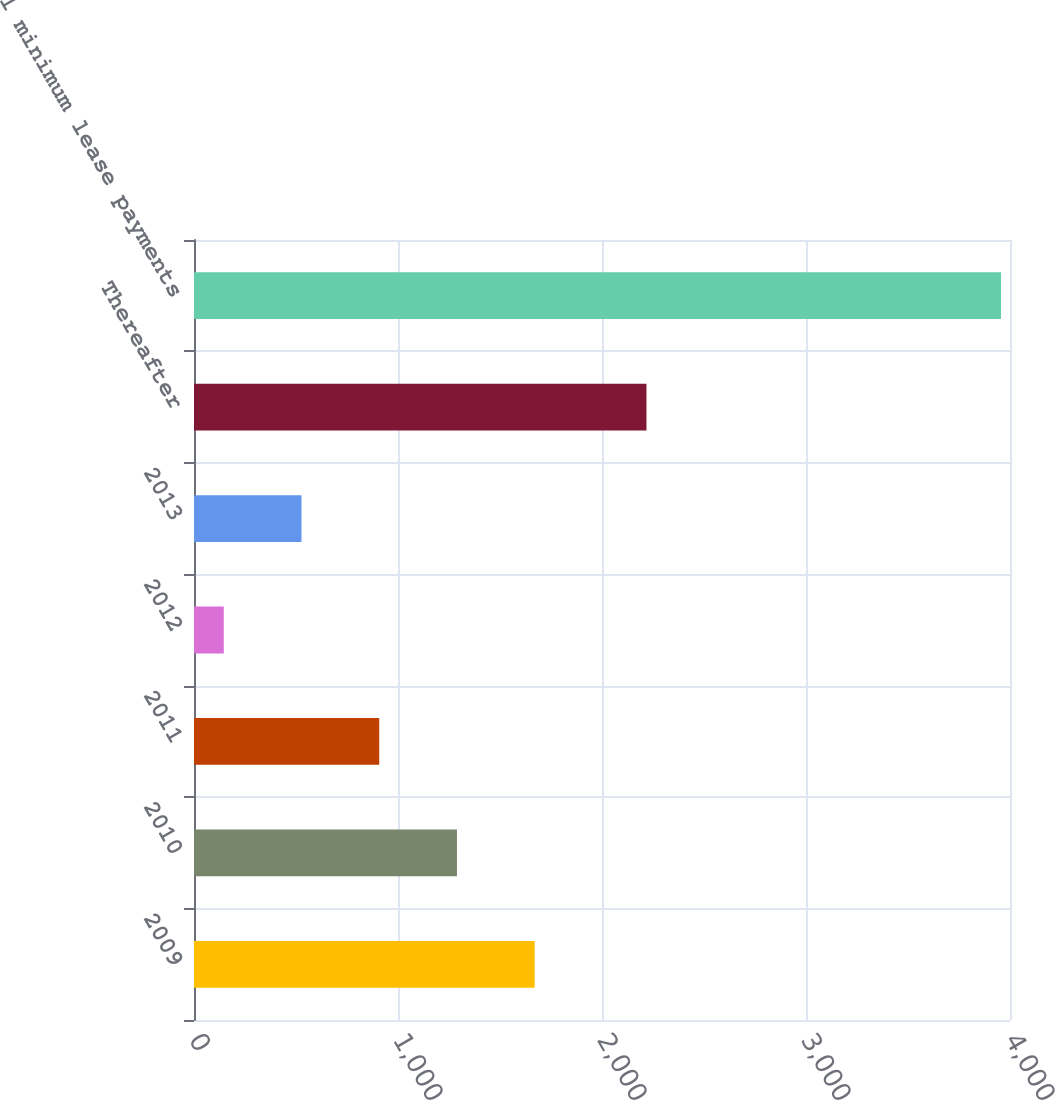Convert chart. <chart><loc_0><loc_0><loc_500><loc_500><bar_chart><fcel>2009<fcel>2010<fcel>2011<fcel>2012<fcel>2013<fcel>Thereafter<fcel>Total minimum lease payments<nl><fcel>1670<fcel>1289<fcel>908<fcel>146<fcel>527<fcel>2218<fcel>3956<nl></chart> 